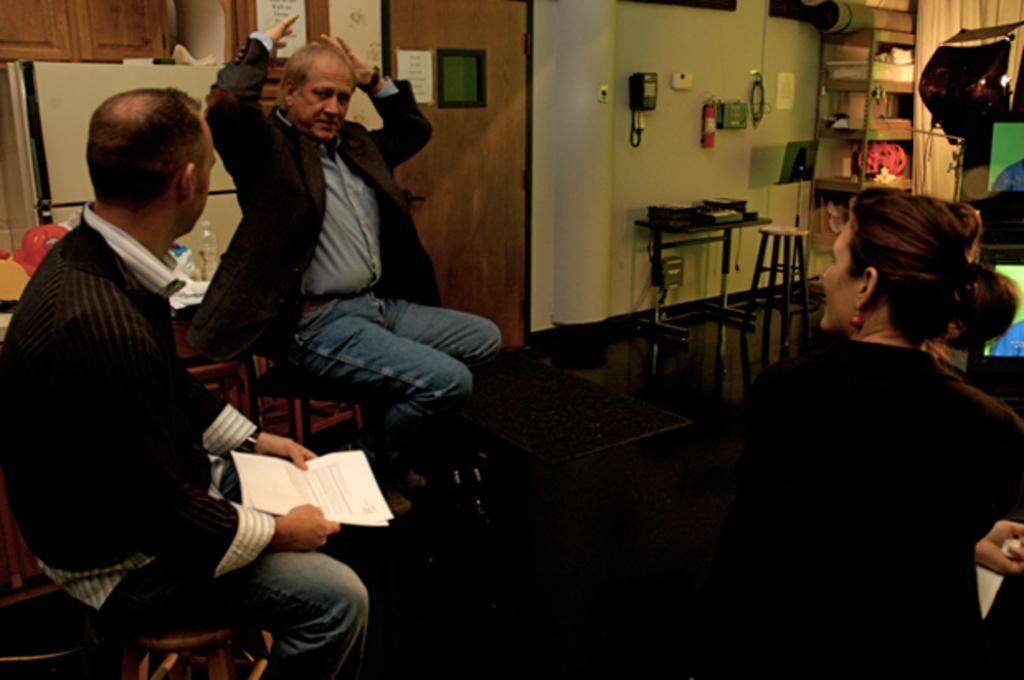Can you describe this image briefly? In this image we can see few people sitting on the chairs, beside we can see the table, on the right we can see some objects, after that we can see curtain, near that we can see shelf unit, we can see some objects on it, after that we can see a table and a few objects on it, on the right we can see few objects. 